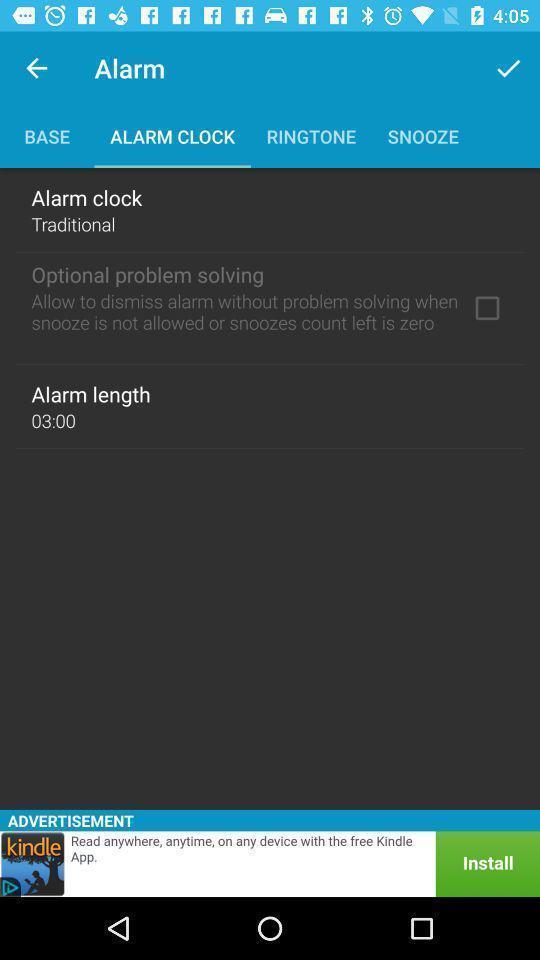What is the overall content of this screenshot? Page showing setting options. 